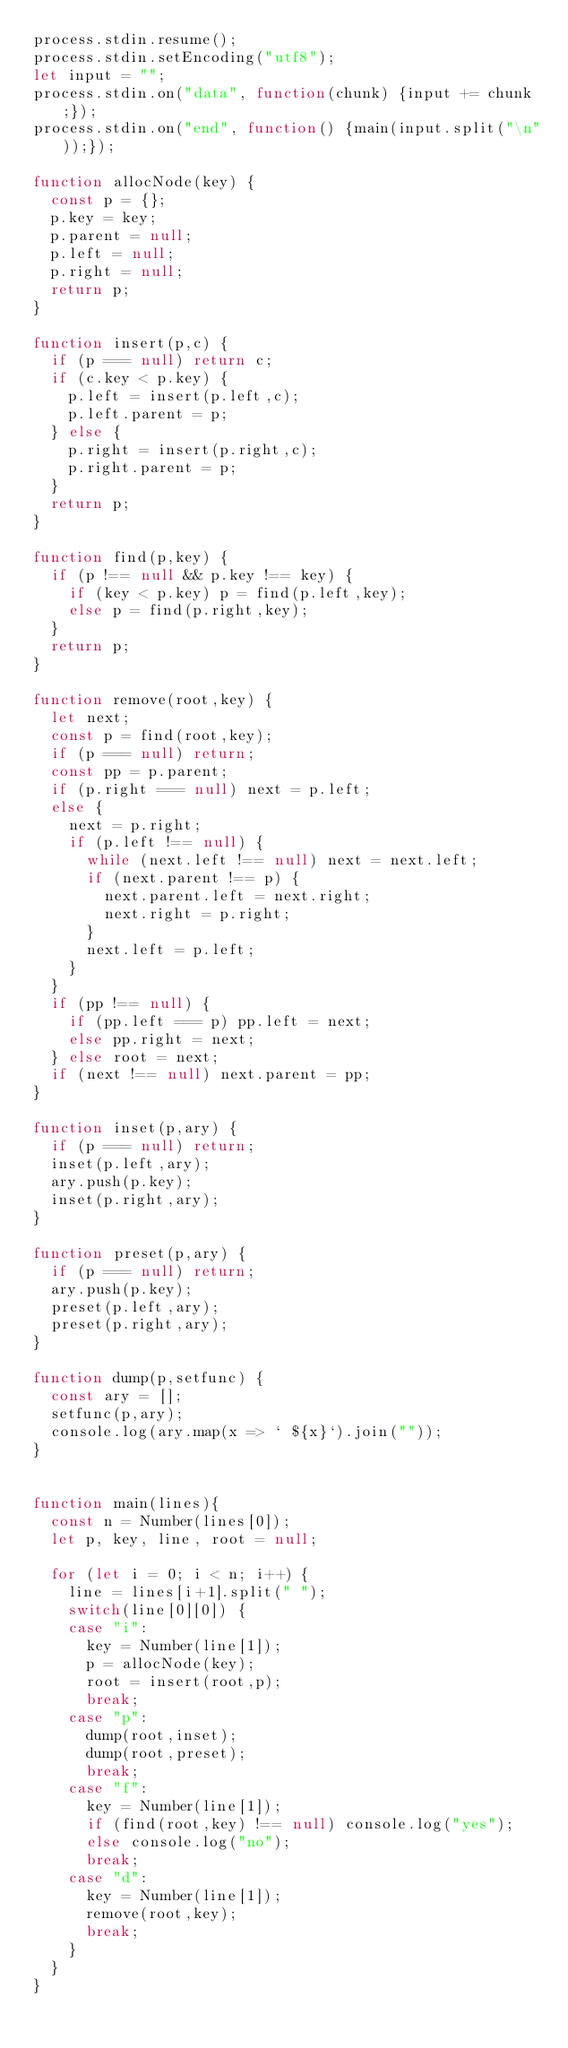Convert code to text. <code><loc_0><loc_0><loc_500><loc_500><_JavaScript_>process.stdin.resume();
process.stdin.setEncoding("utf8");
let input = "";
process.stdin.on("data", function(chunk) {input += chunk;});
process.stdin.on("end", function() {main(input.split("\n"));});

function allocNode(key) {
	const p = {};
	p.key = key;
	p.parent = null;
	p.left = null;
	p.right = null;
	return p;
}

function insert(p,c) {
	if (p === null) return c;
	if (c.key < p.key) {
		p.left = insert(p.left,c);
		p.left.parent = p;
	}	else {
		p.right = insert(p.right,c);
		p.right.parent = p;
	}
	return p;
}

function find(p,key) {
	if (p !== null && p.key !== key) {
		if (key < p.key) p = find(p.left,key);
		else p = find(p.right,key);
	}
	return p;
}

function remove(root,key) {
	let next;
	const p = find(root,key);
	if (p === null) return;
	const pp = p.parent;
	if (p.right === null) next = p.left;
	else {
		next = p.right;
		if (p.left !== null) {
			while (next.left !== null) next = next.left;
			if (next.parent !== p) {
				next.parent.left = next.right;
				next.right = p.right;
			}
			next.left = p.left;
		}
	}
	if (pp !== null) {
		if (pp.left === p) pp.left = next;
		else pp.right = next;
	} else root = next;
	if (next !== null) next.parent = pp;
}

function inset(p,ary) {
	if (p === null) return;
	inset(p.left,ary);
	ary.push(p.key);
	inset(p.right,ary);
}

function preset(p,ary) {
	if (p === null) return;
	ary.push(p.key);
	preset(p.left,ary);
	preset(p.right,ary);
}

function dump(p,setfunc) {
	const ary = [];
	setfunc(p,ary);
	console.log(ary.map(x => ` ${x}`).join(""));
}


function main(lines){
	const n = Number(lines[0]);
	let p, key, line, root = null;

	for (let i = 0; i < n; i++) {
		line = lines[i+1].split(" ");
		switch(line[0][0]) {
		case "i":
			key = Number(line[1]);
			p = allocNode(key);
			root = insert(root,p);
			break;
		case "p":
			dump(root,inset);
			dump(root,preset);
			break;
		case "f":
			key = Number(line[1]);
			if (find(root,key) !== null) console.log("yes");
			else console.log("no");
			break;
		case "d":
			key = Number(line[1]);
			remove(root,key);
			break;
		}
	}
}

</code> 